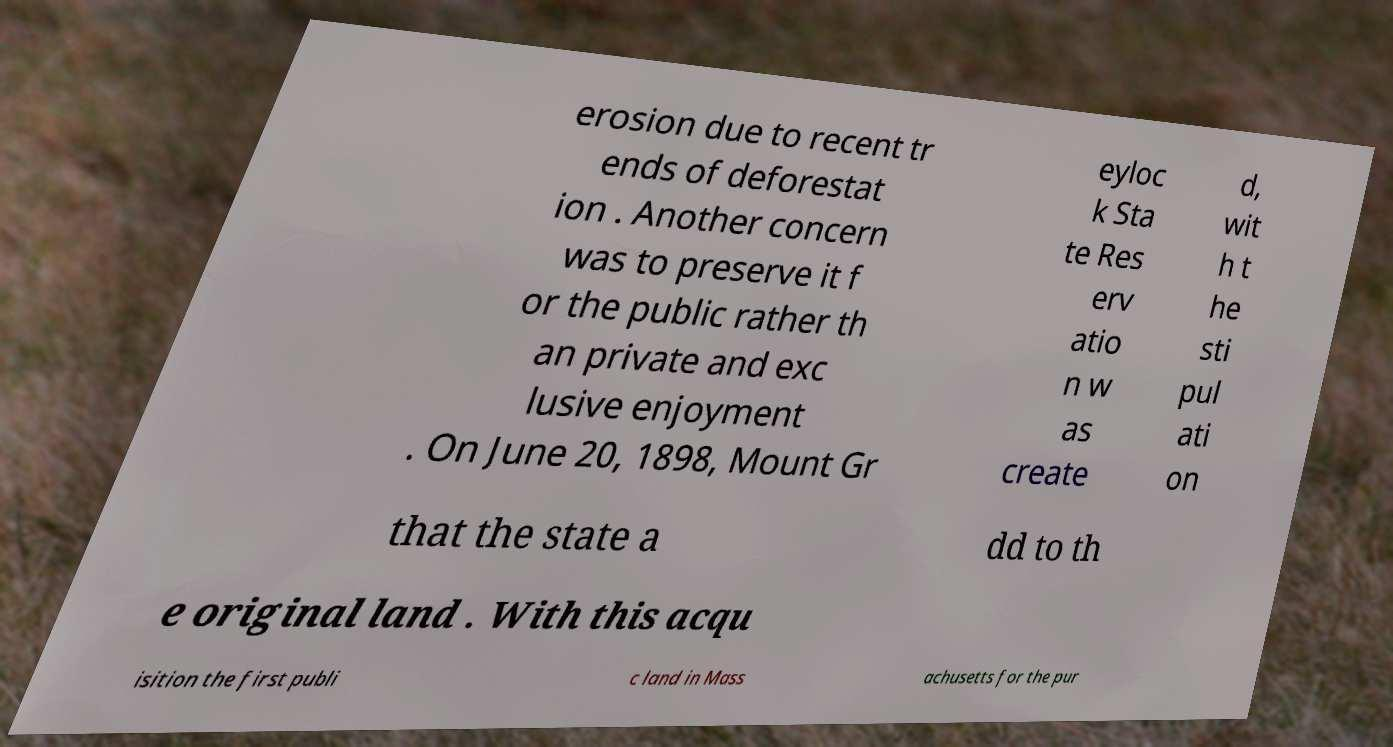Please identify and transcribe the text found in this image. erosion due to recent tr ends of deforestat ion . Another concern was to preserve it f or the public rather th an private and exc lusive enjoyment . On June 20, 1898, Mount Gr eyloc k Sta te Res erv atio n w as create d, wit h t he sti pul ati on that the state a dd to th e original land . With this acqu isition the first publi c land in Mass achusetts for the pur 